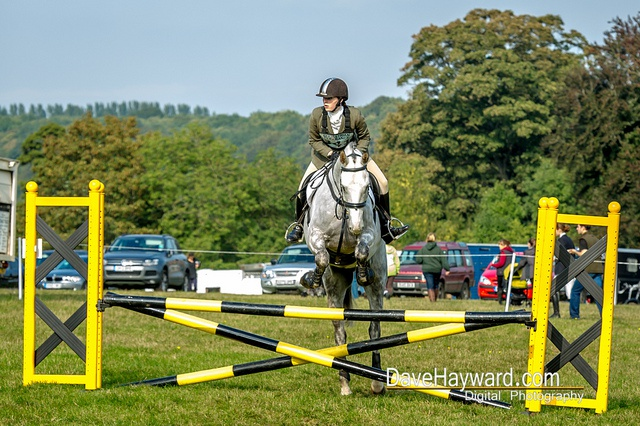Describe the objects in this image and their specific colors. I can see horse in lightblue, black, gray, white, and darkgray tones, people in lightblue, black, gray, and darkgreen tones, car in lightblue, black, gray, and blue tones, car in lightblue, gray, black, brown, and teal tones, and car in lightblue, white, darkgray, gray, and teal tones in this image. 